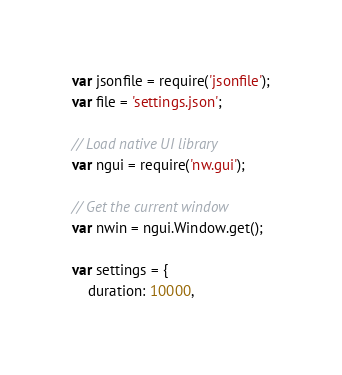Convert code to text. <code><loc_0><loc_0><loc_500><loc_500><_JavaScript_>var jsonfile = require('jsonfile');
var file = 'settings.json';

// Load native UI library
var ngui = require('nw.gui');

// Get the current window
var nwin = ngui.Window.get();

var settings = {
    duration: 10000,</code> 